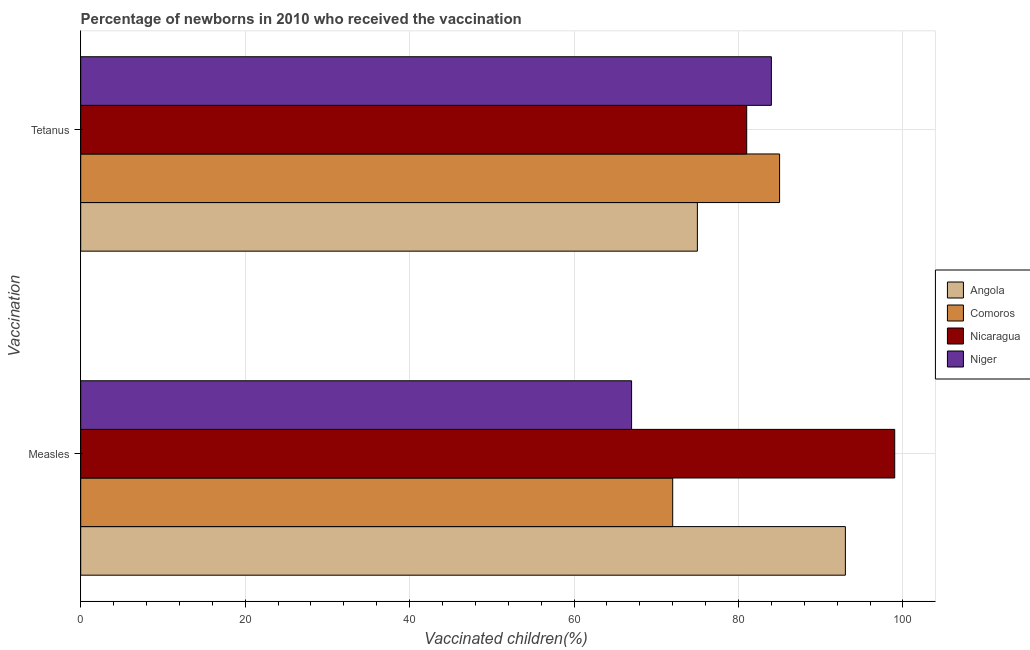How many bars are there on the 1st tick from the top?
Your answer should be very brief. 4. How many bars are there on the 1st tick from the bottom?
Offer a terse response. 4. What is the label of the 2nd group of bars from the top?
Ensure brevity in your answer.  Measles. What is the percentage of newborns who received vaccination for measles in Comoros?
Your answer should be very brief. 72. Across all countries, what is the maximum percentage of newborns who received vaccination for tetanus?
Provide a succinct answer. 85. Across all countries, what is the minimum percentage of newborns who received vaccination for measles?
Keep it short and to the point. 67. In which country was the percentage of newborns who received vaccination for measles maximum?
Provide a short and direct response. Nicaragua. In which country was the percentage of newborns who received vaccination for measles minimum?
Your answer should be compact. Niger. What is the total percentage of newborns who received vaccination for tetanus in the graph?
Provide a succinct answer. 325. What is the difference between the percentage of newborns who received vaccination for tetanus in Angola and that in Niger?
Your answer should be very brief. -9. What is the difference between the percentage of newborns who received vaccination for tetanus in Nicaragua and the percentage of newborns who received vaccination for measles in Comoros?
Your answer should be very brief. 9. What is the average percentage of newborns who received vaccination for measles per country?
Make the answer very short. 82.75. What is the difference between the percentage of newborns who received vaccination for tetanus and percentage of newborns who received vaccination for measles in Angola?
Make the answer very short. -18. In how many countries, is the percentage of newborns who received vaccination for tetanus greater than 16 %?
Offer a terse response. 4. What is the ratio of the percentage of newborns who received vaccination for measles in Angola to that in Nicaragua?
Keep it short and to the point. 0.94. In how many countries, is the percentage of newborns who received vaccination for tetanus greater than the average percentage of newborns who received vaccination for tetanus taken over all countries?
Make the answer very short. 2. What does the 4th bar from the top in Tetanus represents?
Ensure brevity in your answer.  Angola. What does the 1st bar from the bottom in Measles represents?
Ensure brevity in your answer.  Angola. How many bars are there?
Give a very brief answer. 8. What is the difference between two consecutive major ticks on the X-axis?
Your response must be concise. 20. Does the graph contain grids?
Ensure brevity in your answer.  Yes. How many legend labels are there?
Provide a succinct answer. 4. How are the legend labels stacked?
Make the answer very short. Vertical. What is the title of the graph?
Give a very brief answer. Percentage of newborns in 2010 who received the vaccination. Does "Mozambique" appear as one of the legend labels in the graph?
Offer a terse response. No. What is the label or title of the X-axis?
Your answer should be compact. Vaccinated children(%)
. What is the label or title of the Y-axis?
Offer a terse response. Vaccination. What is the Vaccinated children(%)
 of Angola in Measles?
Keep it short and to the point. 93. What is the Vaccinated children(%)
 of Angola in Tetanus?
Offer a very short reply. 75. What is the Vaccinated children(%)
 in Niger in Tetanus?
Offer a very short reply. 84. Across all Vaccination, what is the maximum Vaccinated children(%)
 of Angola?
Make the answer very short. 93. Across all Vaccination, what is the maximum Vaccinated children(%)
 of Niger?
Your response must be concise. 84. Across all Vaccination, what is the minimum Vaccinated children(%)
 in Angola?
Offer a very short reply. 75. Across all Vaccination, what is the minimum Vaccinated children(%)
 in Comoros?
Your answer should be very brief. 72. Across all Vaccination, what is the minimum Vaccinated children(%)
 of Nicaragua?
Provide a succinct answer. 81. Across all Vaccination, what is the minimum Vaccinated children(%)
 in Niger?
Give a very brief answer. 67. What is the total Vaccinated children(%)
 in Angola in the graph?
Give a very brief answer. 168. What is the total Vaccinated children(%)
 in Comoros in the graph?
Ensure brevity in your answer.  157. What is the total Vaccinated children(%)
 of Nicaragua in the graph?
Your response must be concise. 180. What is the total Vaccinated children(%)
 in Niger in the graph?
Offer a terse response. 151. What is the difference between the Vaccinated children(%)
 of Angola in Measles and that in Tetanus?
Offer a very short reply. 18. What is the difference between the Vaccinated children(%)
 in Comoros in Measles and that in Tetanus?
Offer a very short reply. -13. What is the difference between the Vaccinated children(%)
 of Nicaragua in Measles and that in Tetanus?
Your response must be concise. 18. What is the difference between the Vaccinated children(%)
 of Niger in Measles and that in Tetanus?
Your answer should be very brief. -17. What is the difference between the Vaccinated children(%)
 in Angola in Measles and the Vaccinated children(%)
 in Nicaragua in Tetanus?
Your answer should be compact. 12. What is the average Vaccinated children(%)
 in Angola per Vaccination?
Make the answer very short. 84. What is the average Vaccinated children(%)
 of Comoros per Vaccination?
Keep it short and to the point. 78.5. What is the average Vaccinated children(%)
 in Nicaragua per Vaccination?
Your answer should be compact. 90. What is the average Vaccinated children(%)
 in Niger per Vaccination?
Make the answer very short. 75.5. What is the difference between the Vaccinated children(%)
 of Angola and Vaccinated children(%)
 of Nicaragua in Measles?
Offer a very short reply. -6. What is the difference between the Vaccinated children(%)
 in Angola and Vaccinated children(%)
 in Niger in Measles?
Make the answer very short. 26. What is the difference between the Vaccinated children(%)
 of Comoros and Vaccinated children(%)
 of Nicaragua in Measles?
Offer a very short reply. -27. What is the difference between the Vaccinated children(%)
 of Comoros and Vaccinated children(%)
 of Niger in Measles?
Keep it short and to the point. 5. What is the difference between the Vaccinated children(%)
 of Nicaragua and Vaccinated children(%)
 of Niger in Measles?
Your response must be concise. 32. What is the difference between the Vaccinated children(%)
 of Angola and Vaccinated children(%)
 of Nicaragua in Tetanus?
Your response must be concise. -6. What is the difference between the Vaccinated children(%)
 of Angola and Vaccinated children(%)
 of Niger in Tetanus?
Make the answer very short. -9. What is the difference between the Vaccinated children(%)
 of Nicaragua and Vaccinated children(%)
 of Niger in Tetanus?
Offer a very short reply. -3. What is the ratio of the Vaccinated children(%)
 in Angola in Measles to that in Tetanus?
Provide a short and direct response. 1.24. What is the ratio of the Vaccinated children(%)
 in Comoros in Measles to that in Tetanus?
Offer a terse response. 0.85. What is the ratio of the Vaccinated children(%)
 of Nicaragua in Measles to that in Tetanus?
Ensure brevity in your answer.  1.22. What is the ratio of the Vaccinated children(%)
 in Niger in Measles to that in Tetanus?
Provide a short and direct response. 0.8. What is the difference between the highest and the second highest Vaccinated children(%)
 in Nicaragua?
Keep it short and to the point. 18. What is the difference between the highest and the lowest Vaccinated children(%)
 in Angola?
Offer a very short reply. 18. What is the difference between the highest and the lowest Vaccinated children(%)
 in Comoros?
Give a very brief answer. 13. 